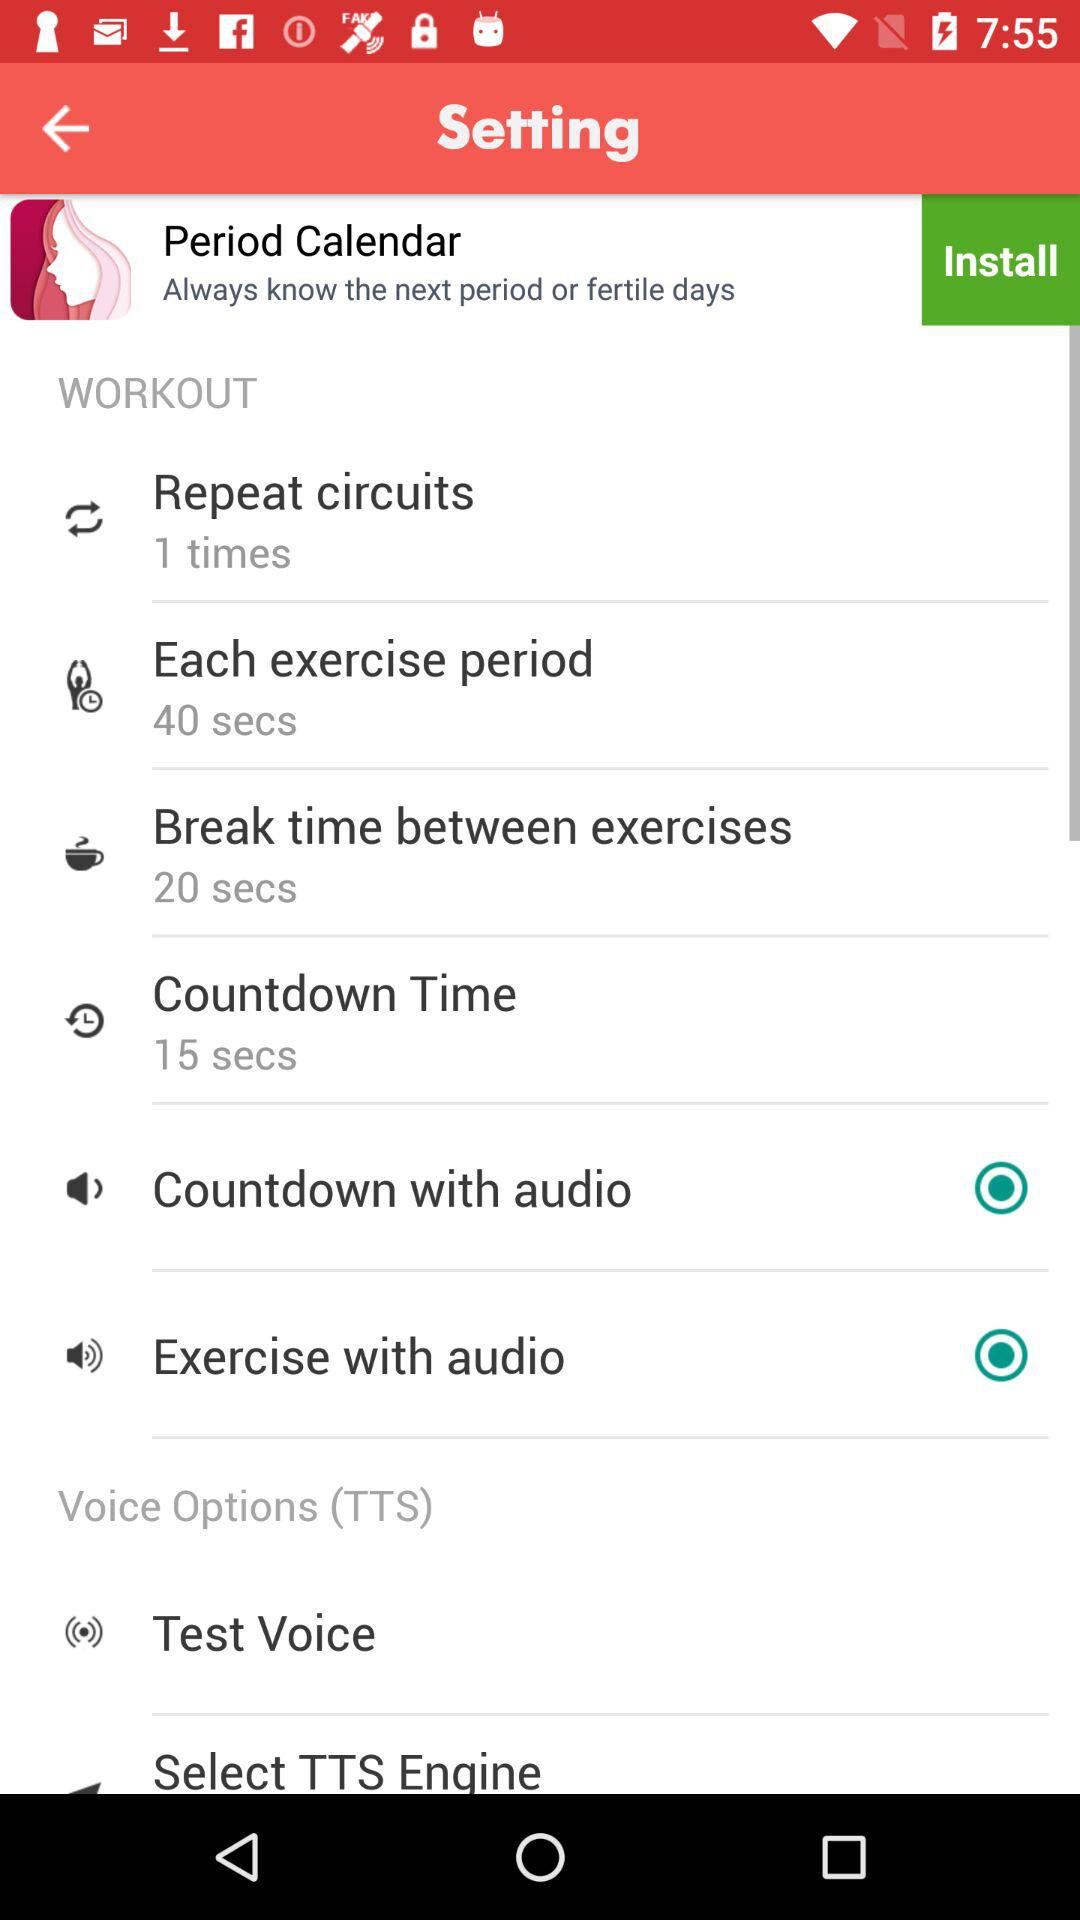How many seconds of break time between exercises? There are 20 seconds of break time between exercises. 